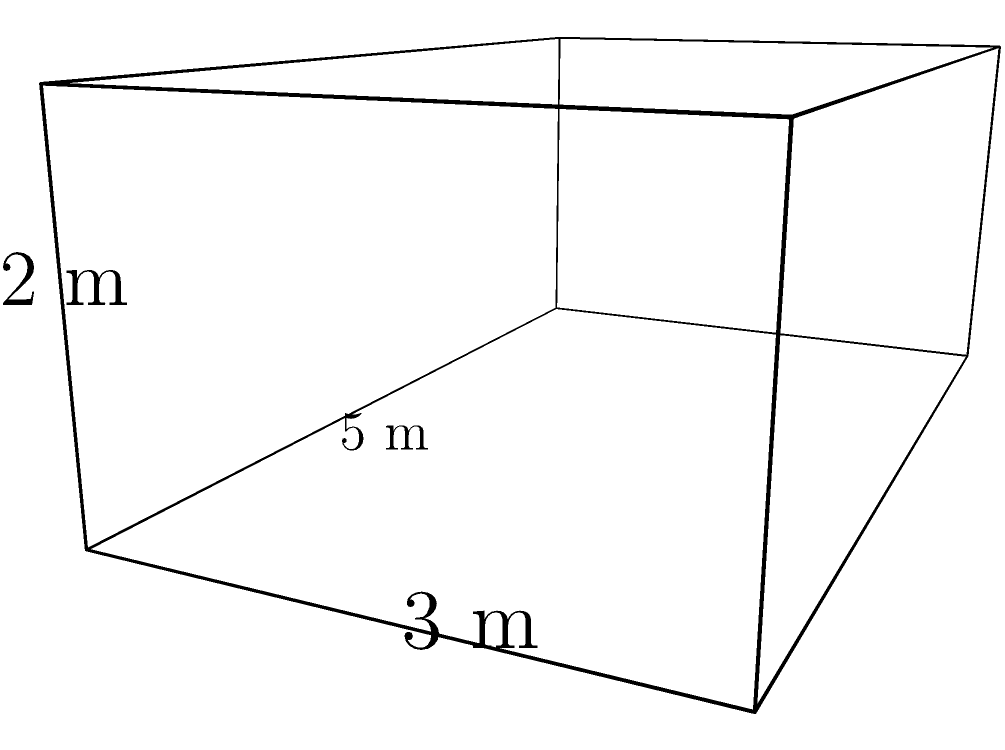As a biologist developing software tools for data analysis, you need to calculate the surface area of a rectangular prism-shaped aquarium tank for a marine life study. The tank measures 5 meters in length, 3 meters in width, and 2 meters in height. What is the total surface area of the tank in square meters? To find the total surface area of a rectangular prism, we need to calculate the area of all six faces and sum them up. Let's break it down step by step:

1. Identify the dimensions:
   Length (l) = 5 m
   Width (w) = 3 m
   Height (h) = 2 m

2. Calculate the areas of each pair of faces:
   a) Front and back faces: 
      $A_1 = 2 \times (w \times h) = 2 \times (3 \times 2) = 12$ m²
   
   b) Left and right faces:
      $A_2 = 2 \times (l \times h) = 2 \times (5 \times 2) = 20$ m²
   
   c) Top and bottom faces:
      $A_3 = 2 \times (l \times w) = 2 \times (5 \times 3) = 30$ m²

3. Sum up all the areas to get the total surface area:
   $A_{total} = A_1 + A_2 + A_3 = 12 + 20 + 30 = 62$ m²

Therefore, the total surface area of the aquarium tank is 62 square meters.
Answer: 62 m² 